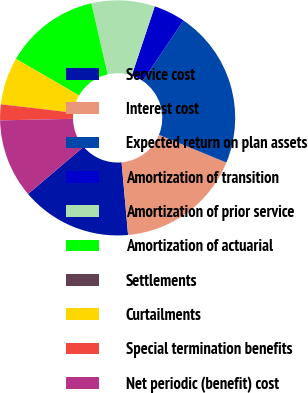Convert chart to OTSL. <chart><loc_0><loc_0><loc_500><loc_500><pie_chart><fcel>Service cost<fcel>Interest cost<fcel>Expected return on plan assets<fcel>Amortization of transition<fcel>Amortization of prior service<fcel>Amortization of actuarial<fcel>Settlements<fcel>Curtailments<fcel>Special termination benefits<fcel>Net periodic (benefit) cost<nl><fcel>15.21%<fcel>17.38%<fcel>21.73%<fcel>4.35%<fcel>8.7%<fcel>13.04%<fcel>0.01%<fcel>6.52%<fcel>2.18%<fcel>10.87%<nl></chart> 